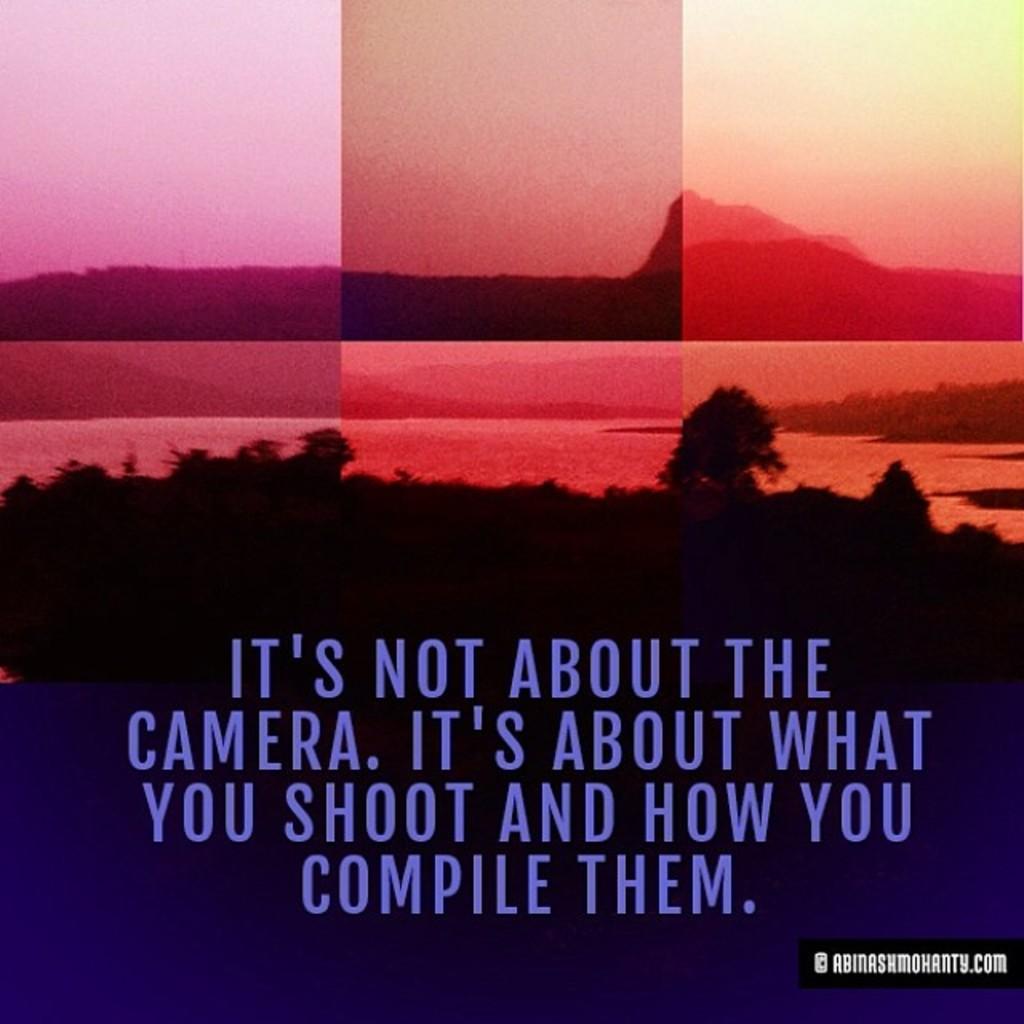What website is this quote attributed to?
Your response must be concise. Abinashmohanty.com. What is quote displayed?
Ensure brevity in your answer.  It's not about the camera. it's about what you shoot and how you compile them. 